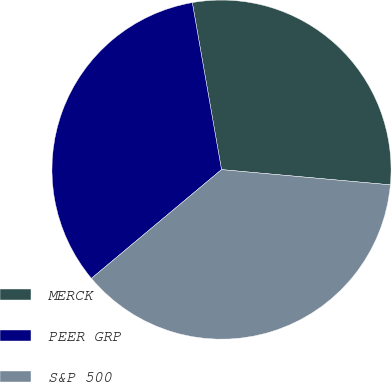Convert chart to OTSL. <chart><loc_0><loc_0><loc_500><loc_500><pie_chart><fcel>MERCK<fcel>PEER GRP<fcel>S&P 500<nl><fcel>29.19%<fcel>33.33%<fcel>37.48%<nl></chart> 